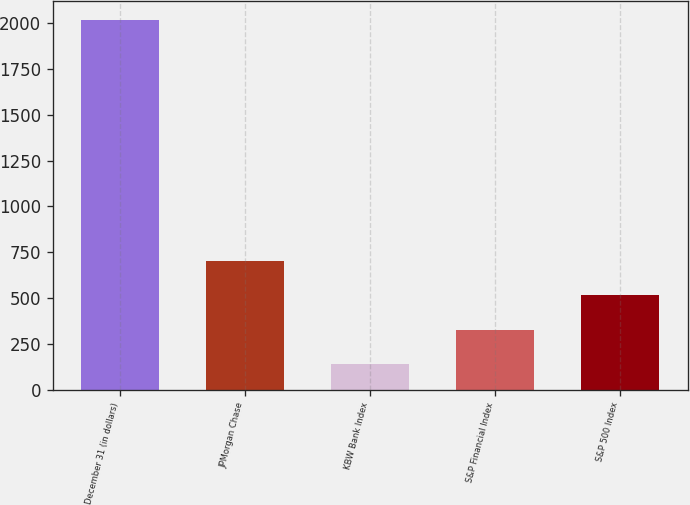Convert chart to OTSL. <chart><loc_0><loc_0><loc_500><loc_500><bar_chart><fcel>December 31 (in dollars)<fcel>JPMorgan Chase<fcel>KBW Bank Index<fcel>S&P Financial Index<fcel>S&P 500 Index<nl><fcel>2018<fcel>701.88<fcel>137.82<fcel>325.84<fcel>513.86<nl></chart> 